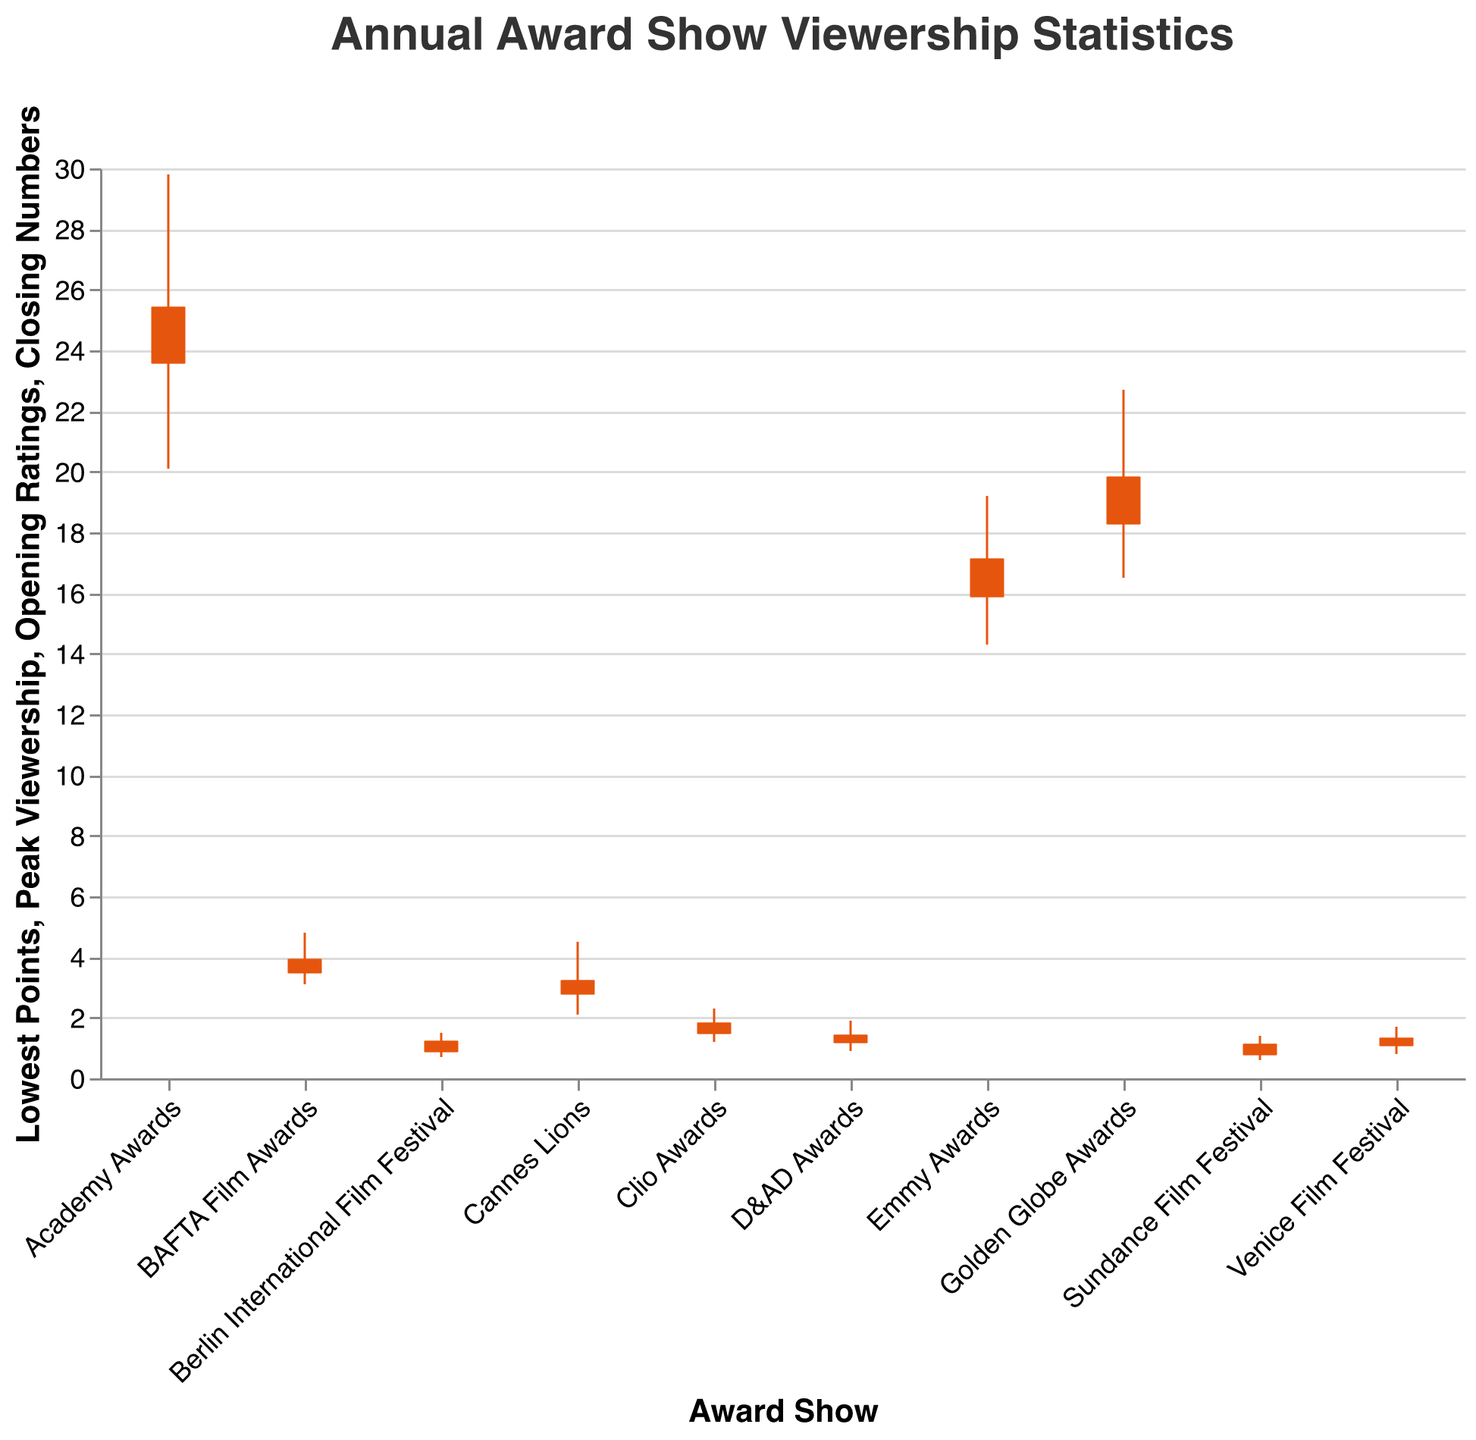Which award show has the highest peak viewership? By looking at the "Peak Viewership" values, the Academy Awards has the highest peak viewership of 29.8.
Answer: Academy Awards What are the opening ratings and closing numbers for the Venice Film Festival? The Venice Film Festival has opening ratings of 1.1 and closing numbers of 1.3 as indicated by the respective sections of the OHLC bar for this award show.
Answer: Opening Ratings: 1.1, Closing Numbers: 1.3 How does the lowest point viewership for the D&AD Awards compare to the Clio Awards? The lowest point viewership for the D&AD Awards is 0.9, while it is 1.2 for the Clio Awards. Comparing these numbers shows that the D&AD Awards has a lower lowest point viewership.
Answer: D&AD Awards has a lower lowest point viewership What is the range of viewership for the Emmy Awards? The range of viewership is calculated as the difference between the peak viewership and the lowest point. For the Emmy Awards, it is 19.2 - 14.3 = 4.9.
Answer: 4.9 Which award show has the smallest difference between opening ratings and closing numbers? By checking the differences between opening ratings and closing numbers for all award shows, the Academy Awards has the smallest difference: 25.4 - 23.6 = 1.8.
Answer: Academy Awards What is the average closing number of all the award shows listed? Sum of closing numbers: 25.4 + 3.2 + 19.8 + 1.8 + 17.1 + 1.4 + 3.9 + 1.1 + 1.3 + 1.2 = 76.2. Number of data points = 10. Average = 76.2 / 10 = 7.62.
Answer: 7.62 Which award show has the most significant drop from peak viewership to lowest points? The drop is calculated by subtracting the lowest points from peak viewership. The drops are: Academy Awards: 29.8 - 20.1 = 9.7, Cannes Lions: 4.5 - 2.1 = 2.4, Golden Globe Awards: 22.7 - 16.5 = 6.2, Clio Awards: 2.3 - 1.2 = 1.1, Emmy Awards: 19.2 - 14.3 = 4.9, D&AD Awards: 1.9 - 0.9 = 1, BAFTA Film Awards: 4.8 - 3.1 = 1.7, Sundance Film Festival: 1.4 - 0.6 = 0.8, Venice Film Festival: 1.7 - 0.8 = 0.9, Berlin International Film Festival: 1.5 - 0.7 = 0.8. The Academy Awards has the most significant drop of 9.7.
Answer: Academy Awards For the award shows with peak viewership higher than 20, what is the average opening rating? The relevant shows are Academy Awards (23.6), Golden Globe Awards (18.3), and Emmy Awards (15.9). Only the Academy Awards and Golden Globe Awards have peak viewership higher than 20. Sum of opening ratings: 23.6 + 18.3 = 41.9. Number of shows = 2. Average = 41.9 / 2 = 20.95.
Answer: 20.95 What is the combined peak viewership for all award shows? Sum of peak viewership: 29.8 + 4.5 + 22.7 + 2.3 + 19.2 + 1.9 + 4.8 + 1.4 + 1.7 + 1.5 = 89.8.
Answer: 89.8 